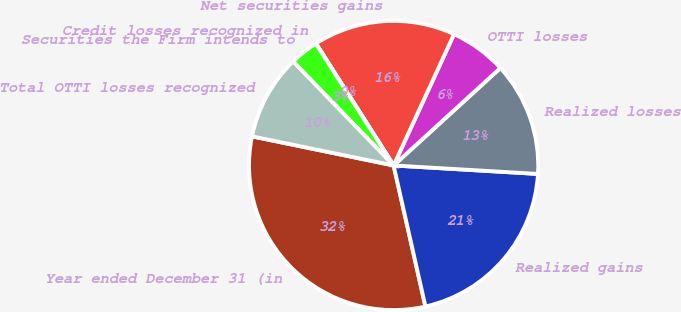Convert chart to OTSL. <chart><loc_0><loc_0><loc_500><loc_500><pie_chart><fcel>Year ended December 31 (in<fcel>Realized gains<fcel>Realized losses<fcel>OTTI losses<fcel>Net securities gains<fcel>Credit losses recognized in<fcel>Securities the Firm intends to<fcel>Total OTTI losses recognized<nl><fcel>31.76%<fcel>20.54%<fcel>12.71%<fcel>6.36%<fcel>15.89%<fcel>0.02%<fcel>3.19%<fcel>9.54%<nl></chart> 